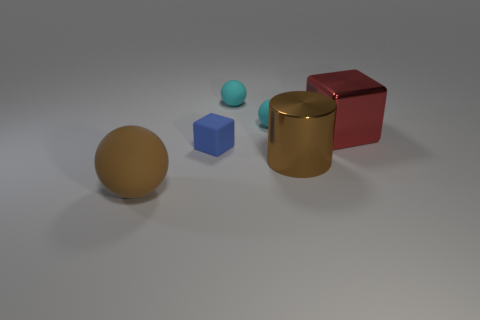Could you describe the lighting and atmosphere of the scene depicted in the image? The scene is softly lit with diffuse, ambient light, creating gentle shadows to the right of the objects indicating a light source to the left, out of frame. The lighting gives the image a calm and serene atmosphere, highlighting the materials' textures and the objects' shapes. What might be the purpose of arranging these objects in this way? The arrangement could be for a variety of purposes, such as demonstrating the visual contrasts between different shapes and materials in a 3D rendering tutorial or for showcasing object composition and the effects of lighting on various surfaces within a graphic design context. 